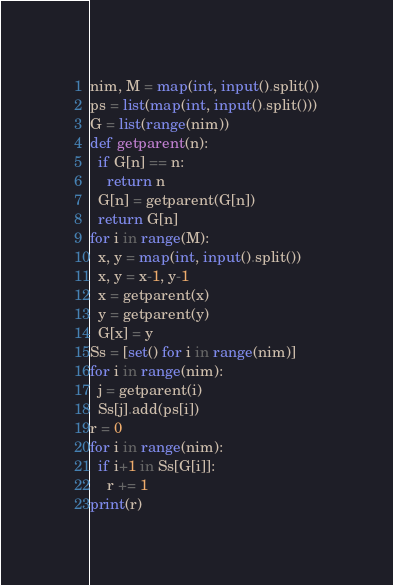Convert code to text. <code><loc_0><loc_0><loc_500><loc_500><_Python_>nim, M = map(int, input().split())
ps = list(map(int, input().split()))
G = list(range(nim))
def getparent(n):
  if G[n] == n:
    return n
  G[n] = getparent(G[n])
  return G[n]
for i in range(M):
  x, y = map(int, input().split())
  x, y = x-1, y-1
  x = getparent(x)
  y = getparent(y)
  G[x] = y
Ss = [set() for i in range(nim)]
for i in range(nim):
  j = getparent(i)
  Ss[j].add(ps[i])
r = 0
for i in range(nim):
  if i+1 in Ss[G[i]]:
    r += 1
print(r)
</code> 